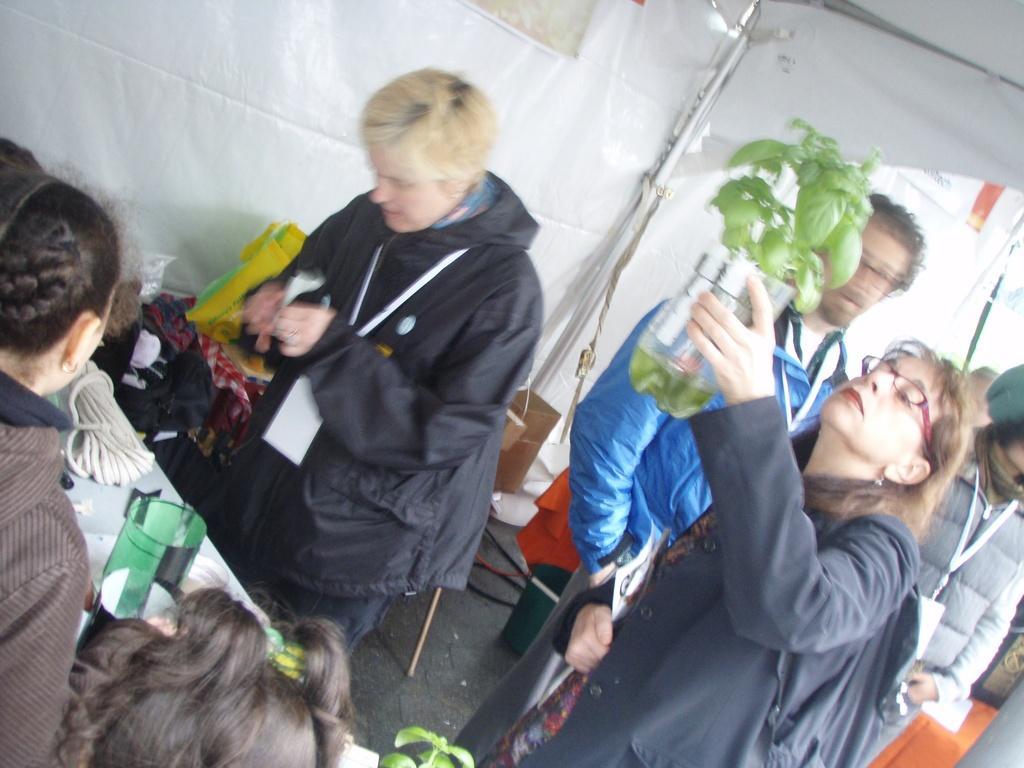Please provide a concise description of this image. In this image I can see a group of people on the floor, chairs, tables, bags, ropes, some objects, houseplant and tent. This image is taken may be during a day. 